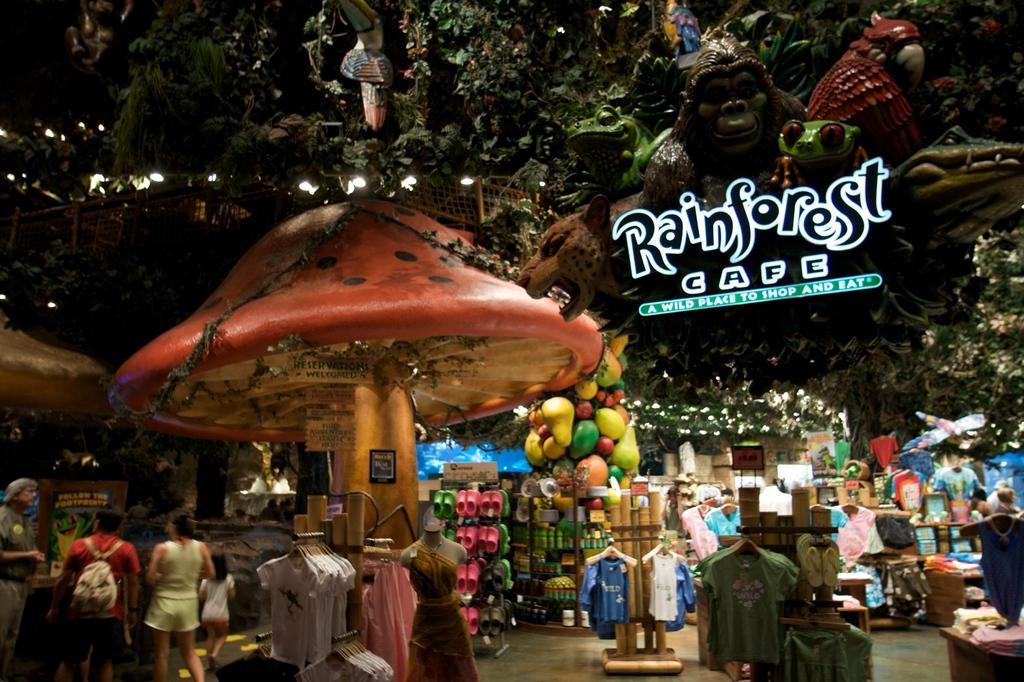Describe this image in one or two sentences. In this picture we can see few people standing on the path on the left side. There are few clothes on the hanging rod. We can see some foot wears in a rack. There is a mannequin. We can see few animals on top left. There are few trees and lights on top. 